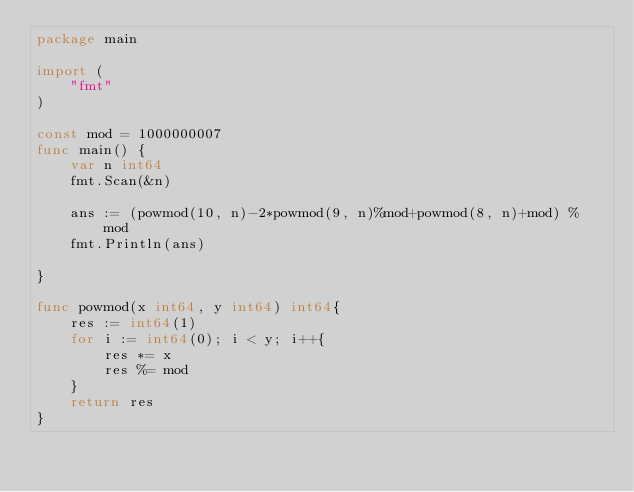Convert code to text. <code><loc_0><loc_0><loc_500><loc_500><_Go_>package main

import (
	"fmt"
)

const mod = 1000000007
func main() {
	var n int64
	fmt.Scan(&n)

	ans := (powmod(10, n)-2*powmod(9, n)%mod+powmod(8, n)+mod) % mod
	fmt.Println(ans)

}

func powmod(x int64, y int64) int64{
	res := int64(1)
	for i := int64(0); i < y; i++{
		res *= x
		res %= mod
	}
	return res
}</code> 